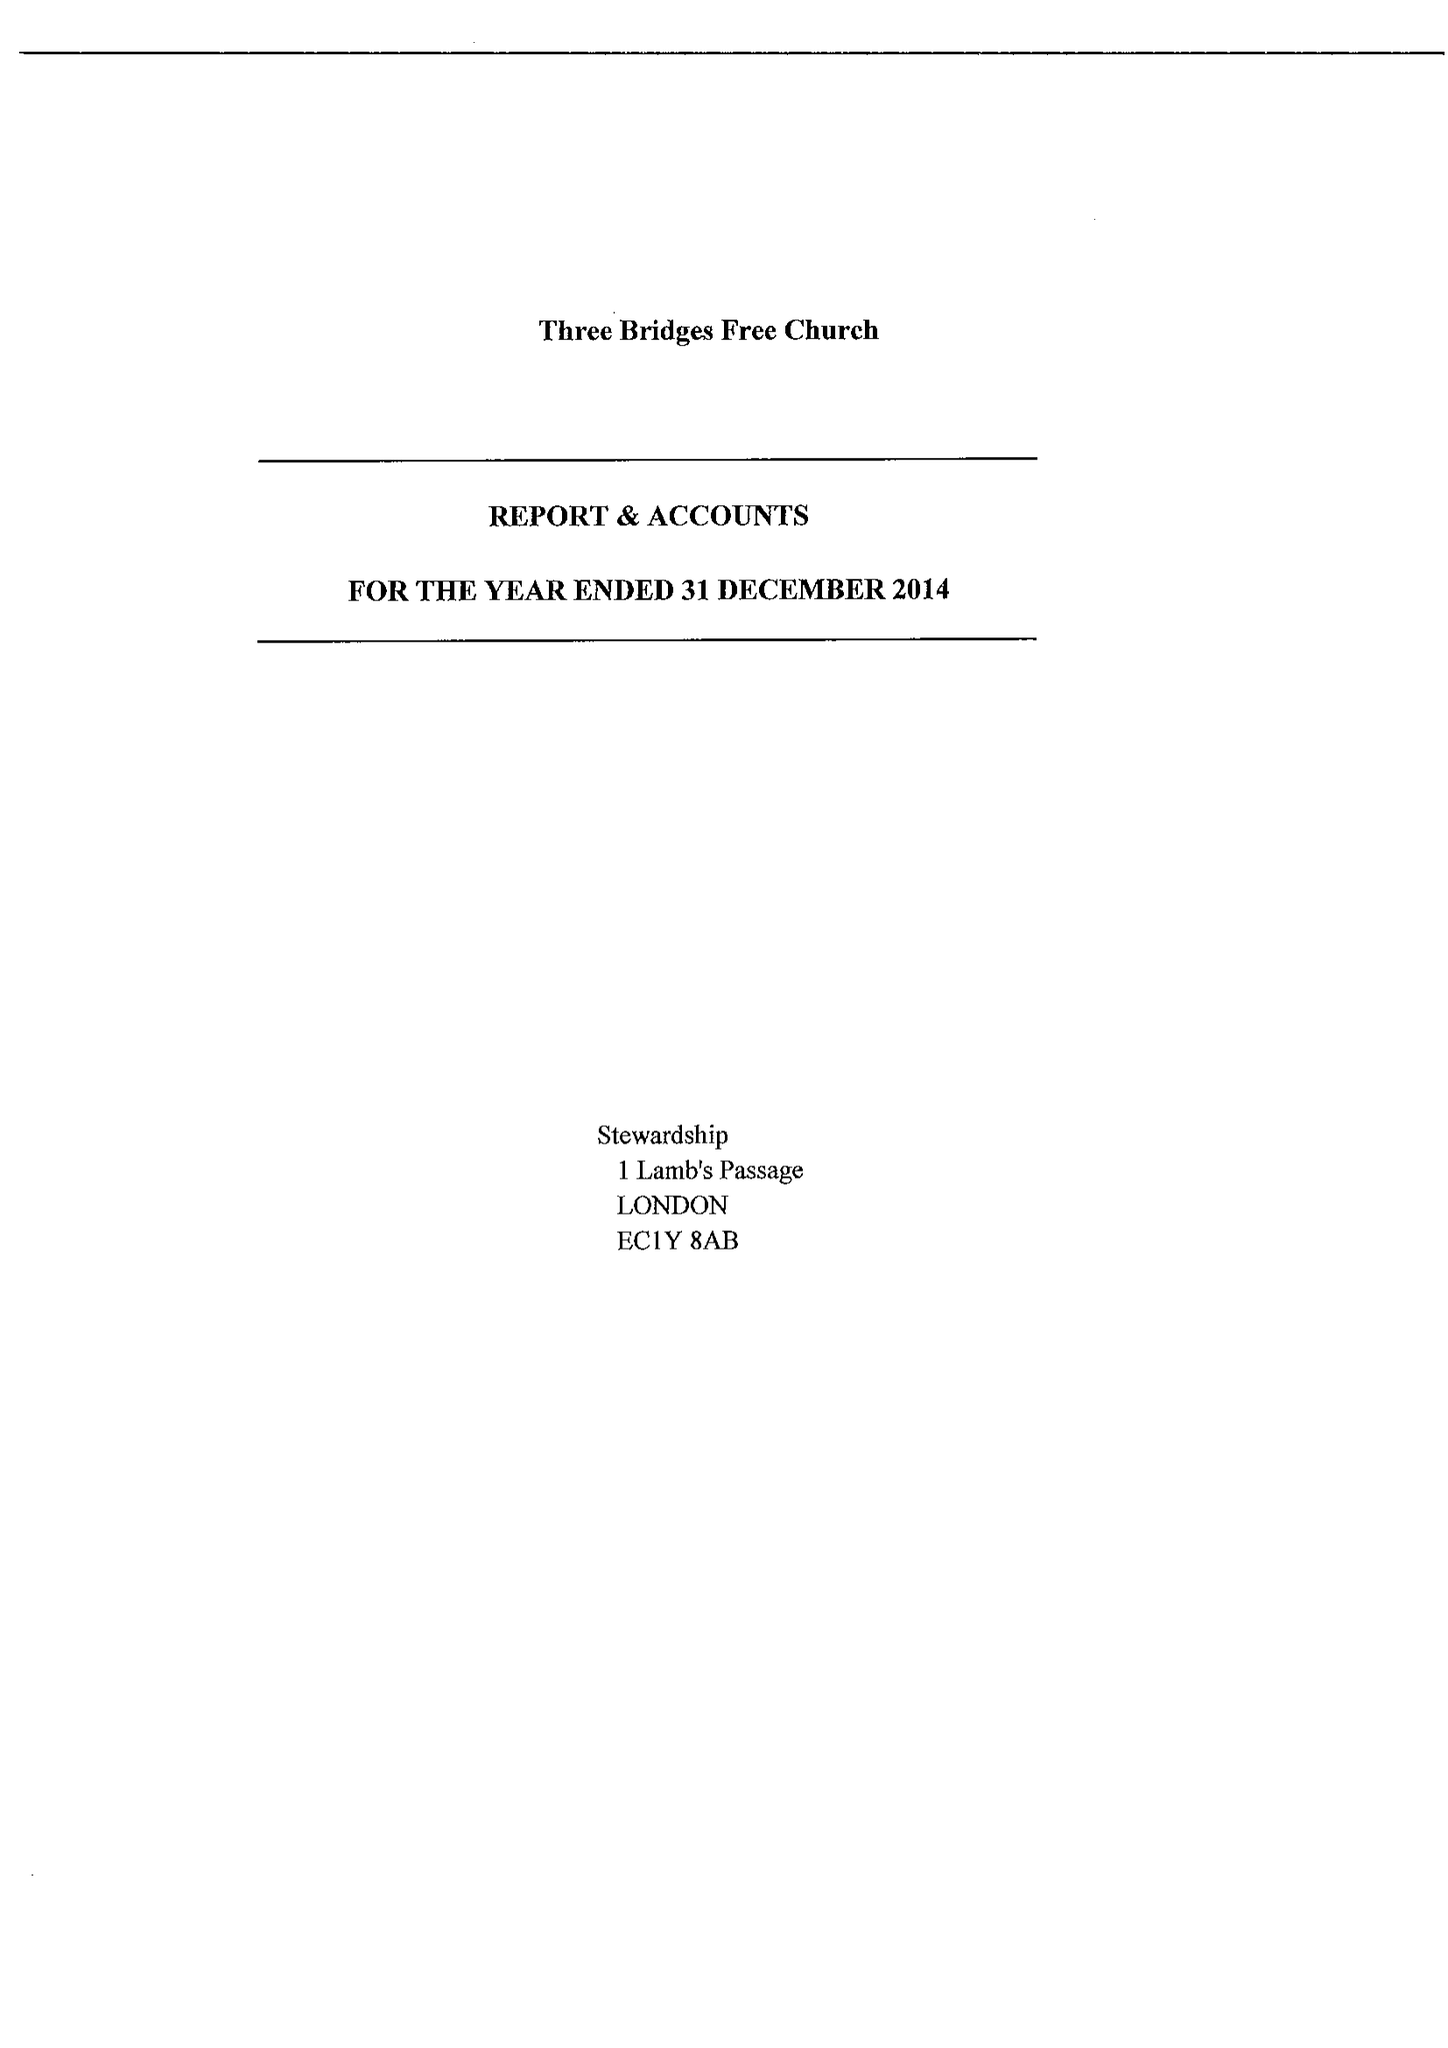What is the value for the income_annually_in_british_pounds?
Answer the question using a single word or phrase. 107652.00 